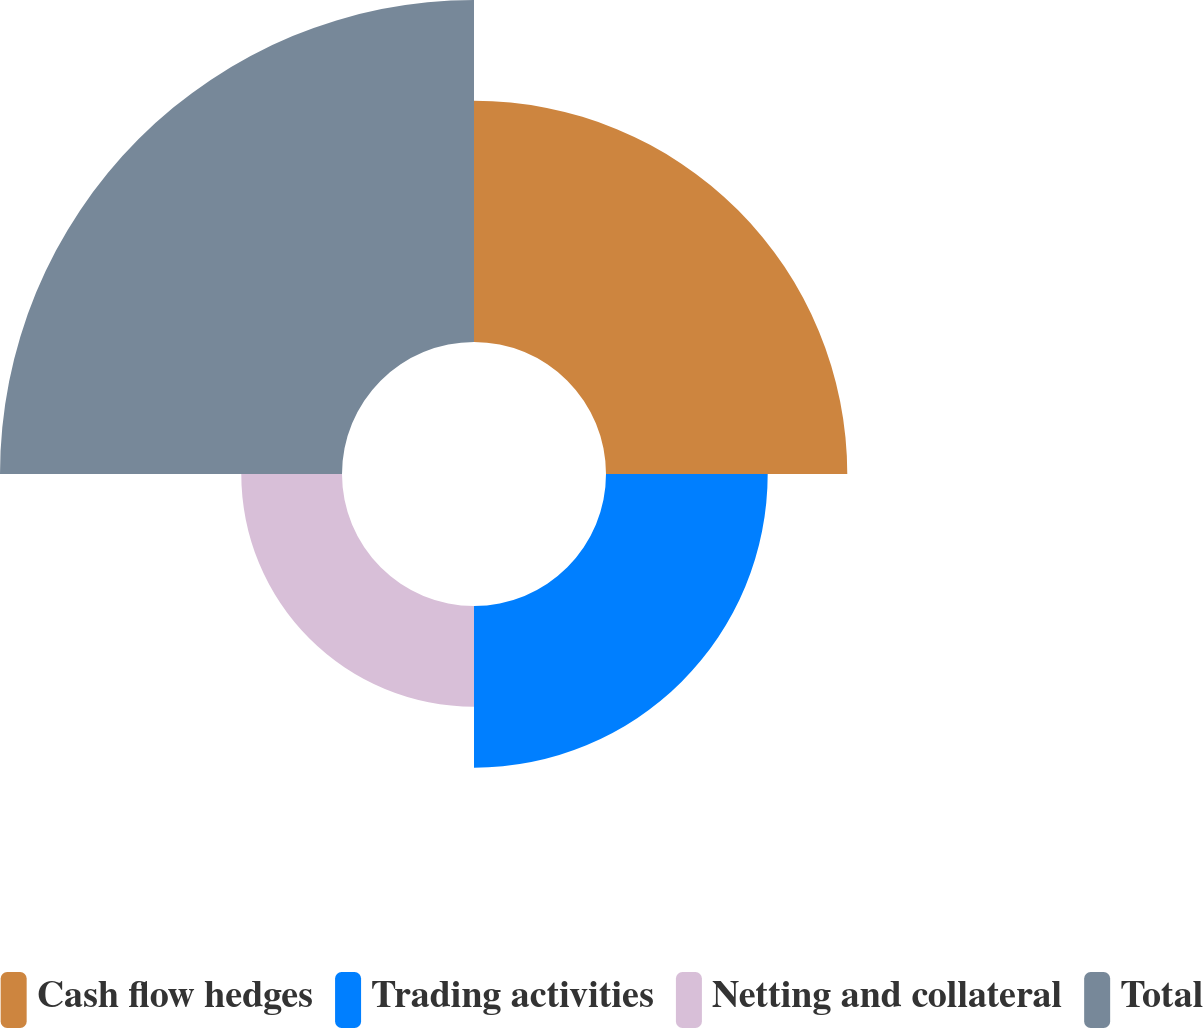<chart> <loc_0><loc_0><loc_500><loc_500><pie_chart><fcel>Cash flow hedges<fcel>Trading activities<fcel>Netting and collateral<fcel>Total<nl><fcel>28.53%<fcel>19.12%<fcel>11.91%<fcel>40.44%<nl></chart> 